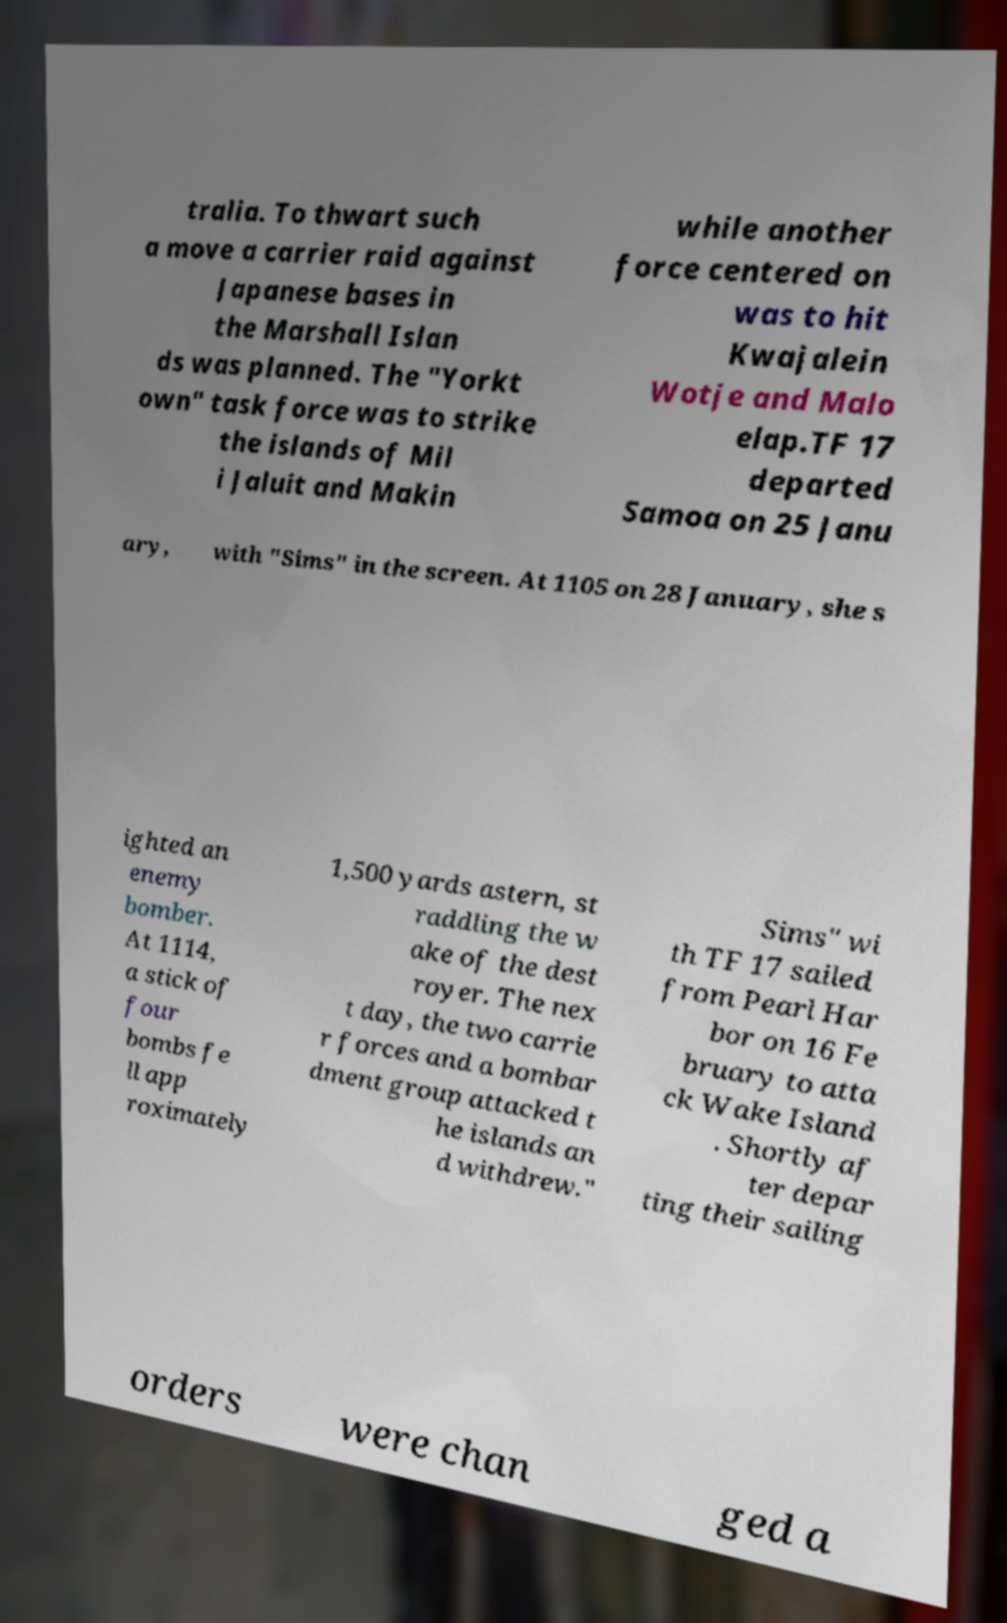There's text embedded in this image that I need extracted. Can you transcribe it verbatim? tralia. To thwart such a move a carrier raid against Japanese bases in the Marshall Islan ds was planned. The "Yorkt own" task force was to strike the islands of Mil i Jaluit and Makin while another force centered on was to hit Kwajalein Wotje and Malo elap.TF 17 departed Samoa on 25 Janu ary, with "Sims" in the screen. At 1105 on 28 January, she s ighted an enemy bomber. At 1114, a stick of four bombs fe ll app roximately 1,500 yards astern, st raddling the w ake of the dest royer. The nex t day, the two carrie r forces and a bombar dment group attacked t he islands an d withdrew." Sims" wi th TF 17 sailed from Pearl Har bor on 16 Fe bruary to atta ck Wake Island . Shortly af ter depar ting their sailing orders were chan ged a 